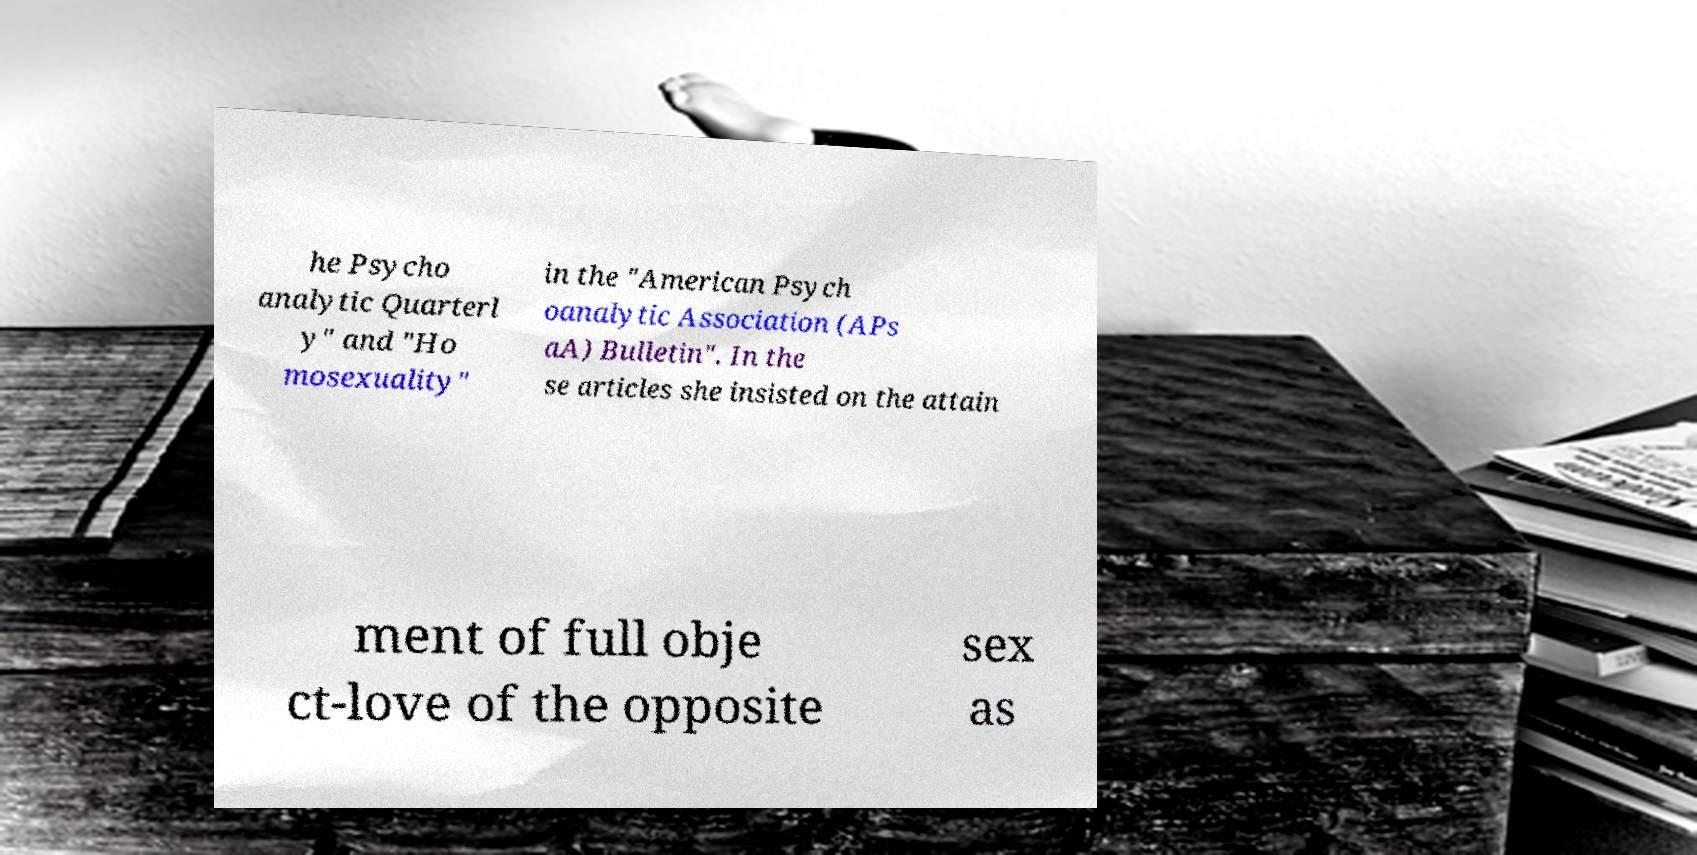Please identify and transcribe the text found in this image. he Psycho analytic Quarterl y" and "Ho mosexuality" in the "American Psych oanalytic Association (APs aA) Bulletin". In the se articles she insisted on the attain ment of full obje ct-love of the opposite sex as 